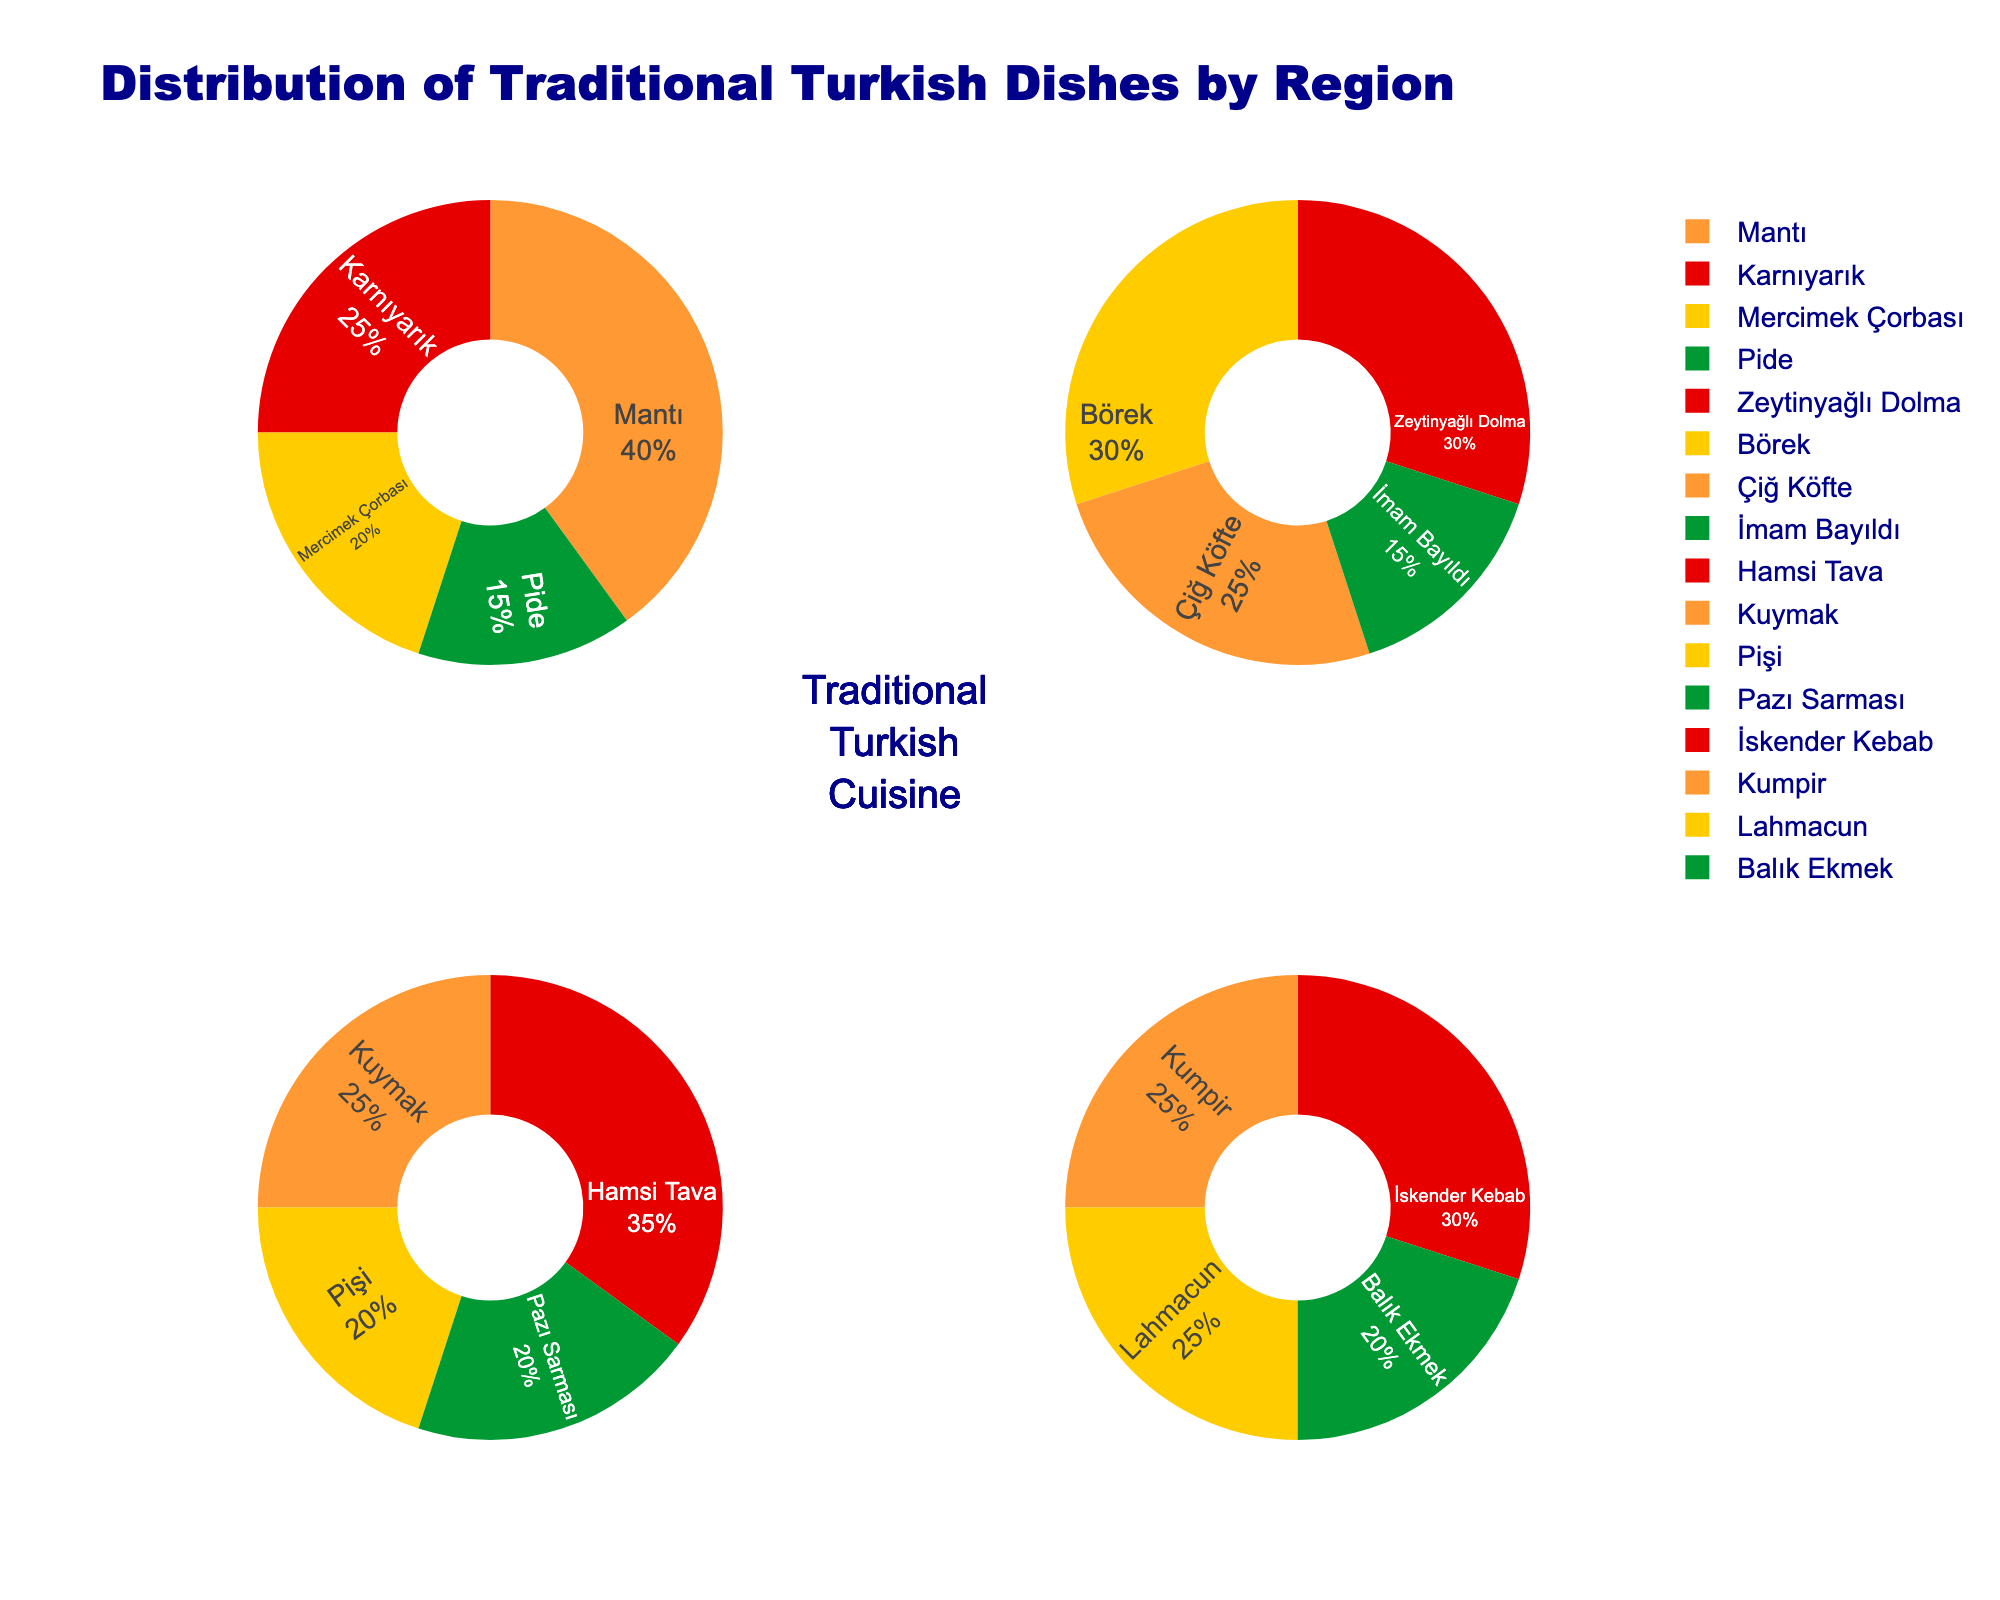Which region has the highest percentage of Mantı consumption? To determine this, look at the pie charts and identify the percentage of Mantı in each region. Mantı appears in Central Anatolia with a percentage of 40%.
Answer: Central Anatolia What is the most consumed dish in the Black Sea region? Look at the Black Sea pie chart and identify the dish with the largest section. Hamsi Tava has the largest section with 35%.
Answer: Hamsi Tava How does the percentage of İmam Bayıldı consumption in the Aegean region compare to the percentage of Kuymak consumption in the Black Sea region? Find the percentage of İmam Bayıldı in the Aegean region, which is 15%, and compare it to the percentage of Kuymak in the Black Sea region, which is 25%. 15% is less than 25%.
Answer: Less Which two dishes have the same percentage of consumption in the Aegean region? In the Aegean region pie chart, compare the percentages of each dish. Both Zeytinyağlı Dolma and Börek have a percentage of 30%.
Answer: Zeytinyağlı Dolma and Börek What is the combined percentage of Karnıyarık and Pide in the Central Anatolia region? Find the percentages of Karnıyarık and Pide in the Central Anatolia region (25% and 15% respectively) and add them up. 25% + 15% = 40%.
Answer: 40% How many dishes are represented in the Marmara region pie chart? Count the number of different sections (dishes) in the Marmara region pie chart. There are four dishes: İskender Kebab, Kumpir, Lahmacun, and Balık Ekmek.
Answer: Four Which region has the least diversity in dish consumption, based on the number of different dishes? Count the number of different dishes in each region's pie chart. Each region has four dishes, so they all have the same diversity in terms of the number of dishes.
Answer: All regions have the same diversity What is the second most consumed dish in the Central Anatolia region? In the Central Anatolia region pie chart, identify the dish with the second largest section. Mantı is the most consumed, followed by Karnıyarık with 25%.
Answer: Karnıyarık 